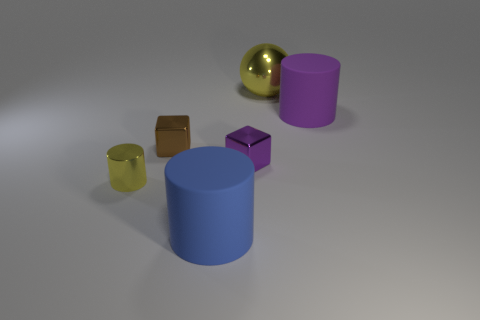Is there any coherence in the arrangement of the objects, or does it appear random? The objects are arranged without a clear pattern, seemingly placed randomly on the surface. There appears to be no intentional alignment or organization amongst the shapes, creating a sense of informal spatial distribution. 